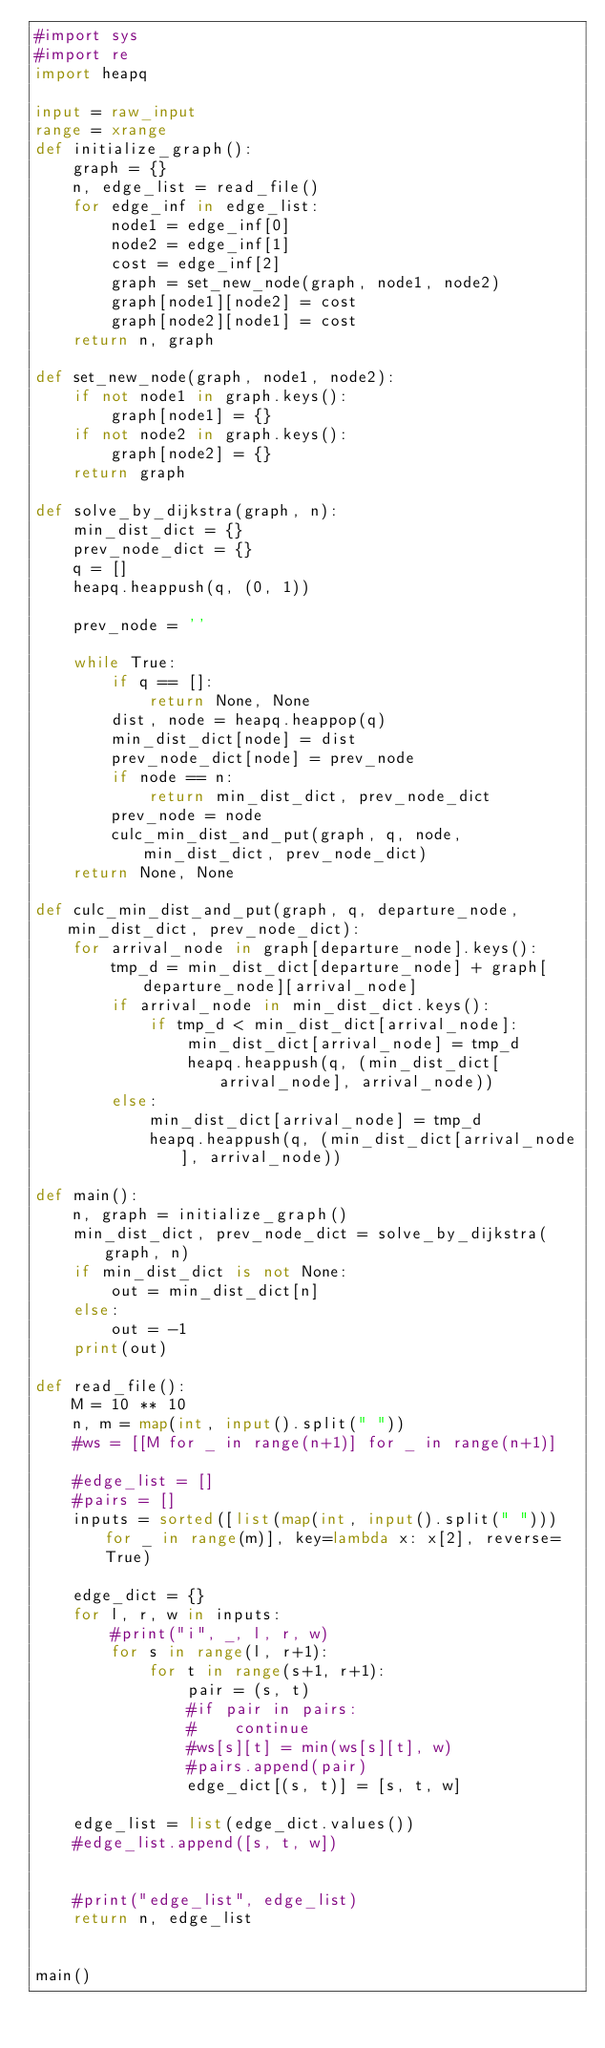Convert code to text. <code><loc_0><loc_0><loc_500><loc_500><_Python_>#import sys
#import re
import heapq

input = raw_input
range = xrange
def initialize_graph():
    graph = {}
    n, edge_list = read_file()
    for edge_inf in edge_list:
        node1 = edge_inf[0]
        node2 = edge_inf[1]
        cost = edge_inf[2]
        graph = set_new_node(graph, node1, node2)
        graph[node1][node2] = cost
        graph[node2][node1] = cost
    return n, graph

def set_new_node(graph, node1, node2):
    if not node1 in graph.keys():
        graph[node1] = {}
    if not node2 in graph.keys():
        graph[node2] = {}
    return graph

def solve_by_dijkstra(graph, n):
    min_dist_dict = {}
    prev_node_dict = {}
    q = []
    heapq.heappush(q, (0, 1))
    
    prev_node = ''

    while True:
        if q == []:
            return None, None
        dist, node = heapq.heappop(q)
        min_dist_dict[node] = dist
        prev_node_dict[node] = prev_node
        if node == n: 
            return min_dist_dict, prev_node_dict
        prev_node = node
        culc_min_dist_and_put(graph, q, node, min_dist_dict, prev_node_dict)
    return None, None

def culc_min_dist_and_put(graph, q, departure_node, min_dist_dict, prev_node_dict):
    for arrival_node in graph[departure_node].keys():
        tmp_d = min_dist_dict[departure_node] + graph[departure_node][arrival_node]
        if arrival_node in min_dist_dict.keys():
            if tmp_d < min_dist_dict[arrival_node]:
                min_dist_dict[arrival_node] = tmp_d
                heapq.heappush(q, (min_dist_dict[arrival_node], arrival_node))
        else:
            min_dist_dict[arrival_node] = tmp_d
            heapq.heappush(q, (min_dist_dict[arrival_node], arrival_node))

def main():
    n, graph = initialize_graph()
    min_dist_dict, prev_node_dict = solve_by_dijkstra(graph, n)
    if min_dist_dict is not None:
        out = min_dist_dict[n]
    else:
        out = -1
    print(out)

def read_file():
    M = 10 ** 10
    n, m = map(int, input().split(" "))
    #ws = [[M for _ in range(n+1)] for _ in range(n+1)]

    #edge_list = []
    #pairs = []
    inputs = sorted([list(map(int, input().split(" "))) for _ in range(m)], key=lambda x: x[2], reverse=True)

    edge_dict = {}
    for l, r, w in inputs:
        #print("i", _, l, r, w)
        for s in range(l, r+1):
            for t in range(s+1, r+1):
                pair = (s, t)
                #if pair in pairs:
                #    continue
                #ws[s][t] = min(ws[s][t], w)
                #pairs.append(pair)
                edge_dict[(s, t)] = [s, t, w]

    edge_list = list(edge_dict.values())
    #edge_list.append([s, t, w])


    #print("edge_list", edge_list)
    return n, edge_list


main()</code> 